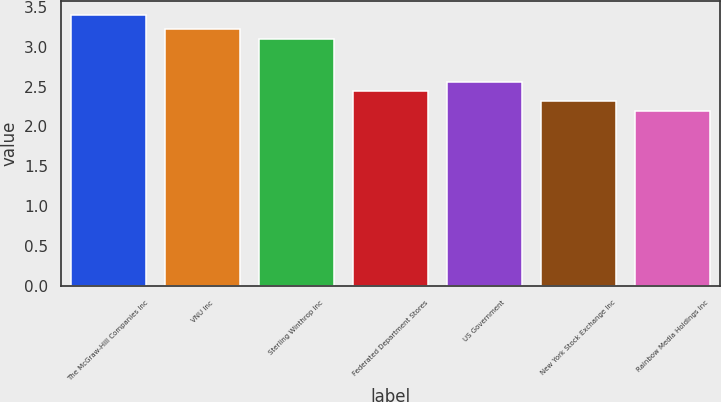<chart> <loc_0><loc_0><loc_500><loc_500><bar_chart><fcel>The McGraw-Hill Companies Inc<fcel>VNU Inc<fcel>Sterling Winthrop Inc<fcel>Federated Department Stores<fcel>US Government<fcel>New York Stock Exchange Inc<fcel>Rainbow Media Holdings Inc<nl><fcel>3.4<fcel>3.22<fcel>3.1<fcel>2.44<fcel>2.56<fcel>2.32<fcel>2.2<nl></chart> 